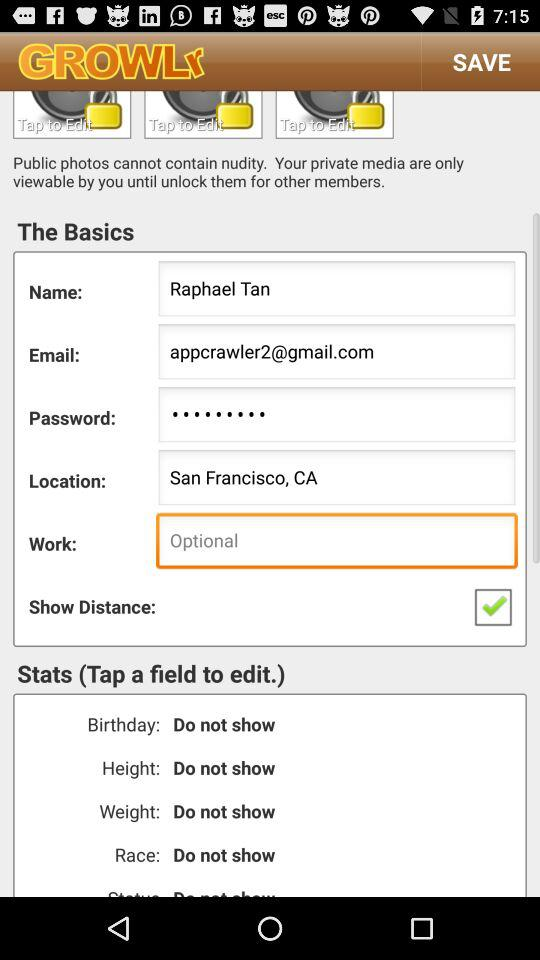What is the user work?
When the provided information is insufficient, respond with <no answer>. <no answer> 